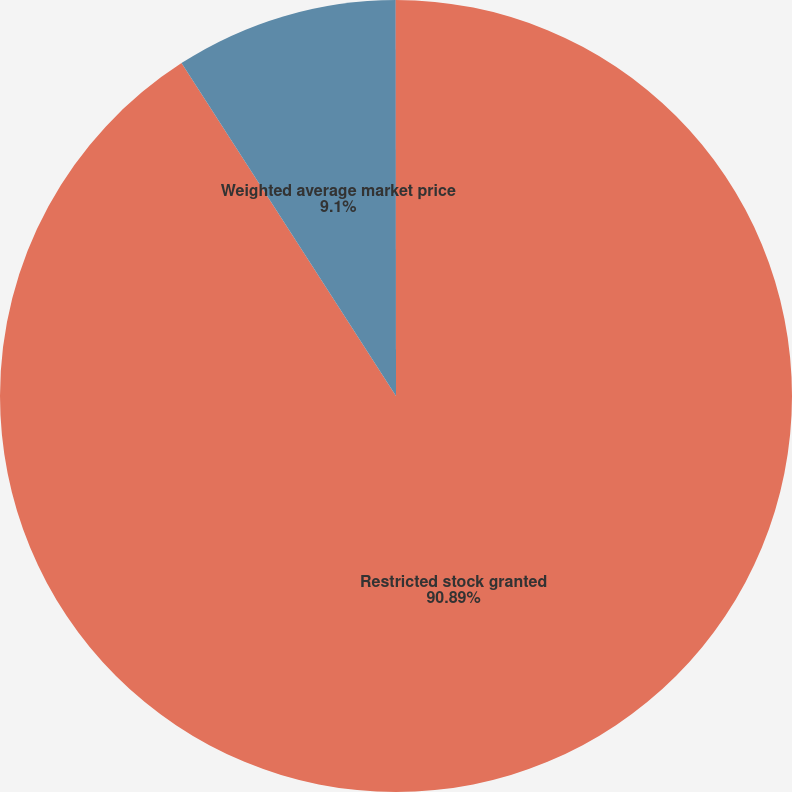Convert chart to OTSL. <chart><loc_0><loc_0><loc_500><loc_500><pie_chart><fcel>Restricted stock granted<fcel>Weighted average market price<fcel>Weighted average vesting<nl><fcel>90.89%<fcel>9.1%<fcel>0.01%<nl></chart> 